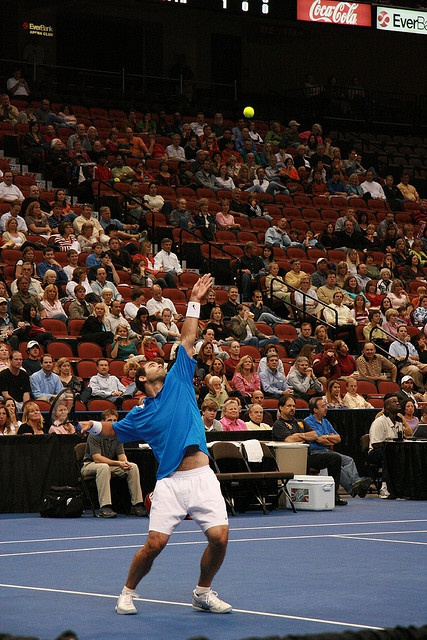Describe the objects in this image and their specific colors. I can see people in black, maroon, and gray tones, chair in black, maroon, brown, and gray tones, people in black, lightgray, blue, and navy tones, chair in black, maroon, and gray tones, and chair in black, ivory, gray, and maroon tones in this image. 